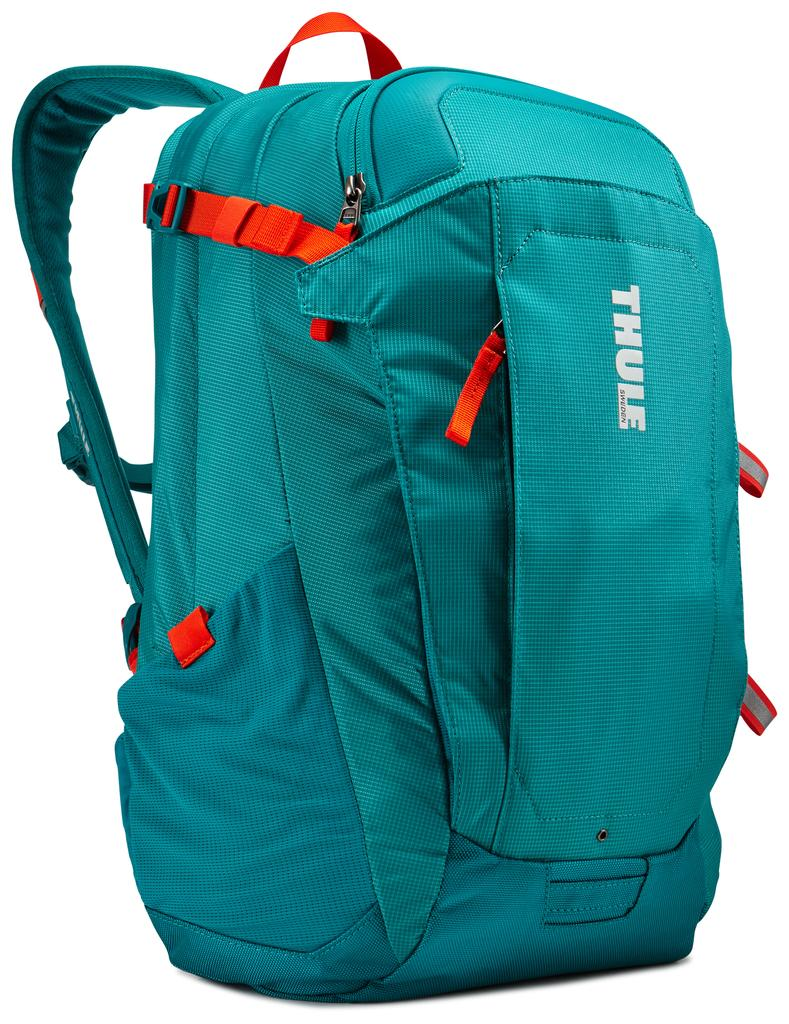<image>
Describe the image concisely. A teal green backpack made by Thule Sweden. 